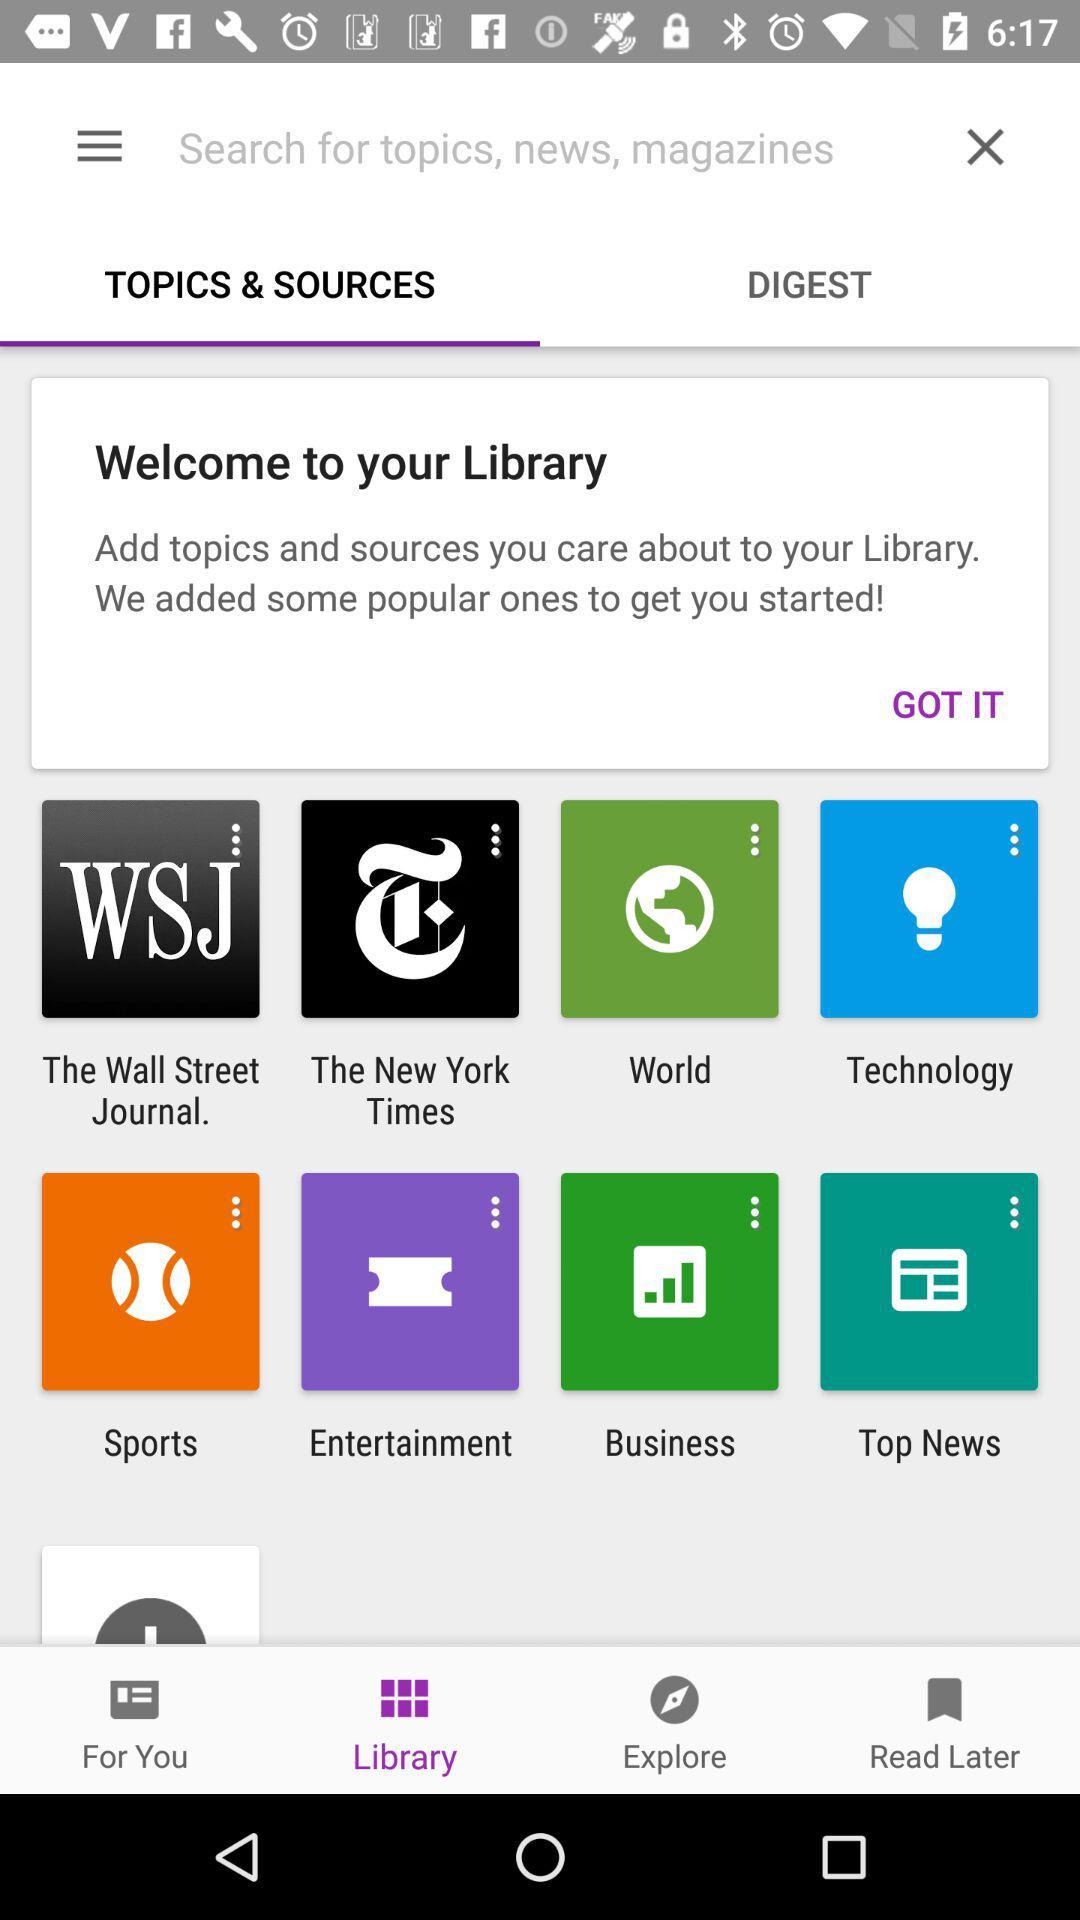Which tab has been selected? The tabs that have been selected are "Library" and "TOPICS & SOURCES". 